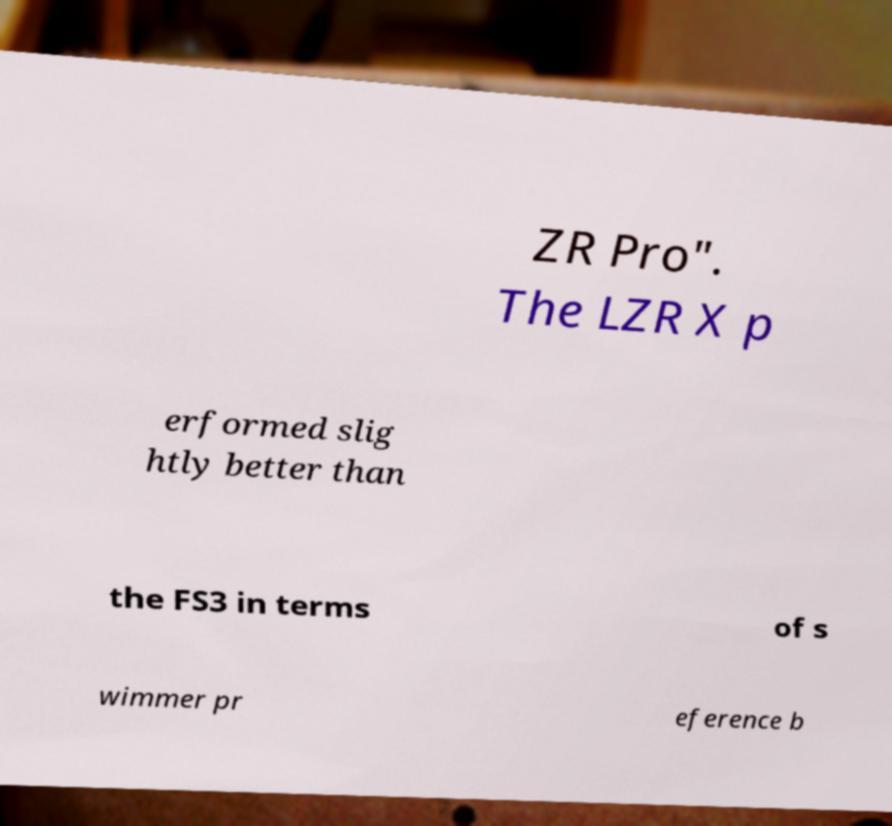I need the written content from this picture converted into text. Can you do that? ZR Pro". The LZR X p erformed slig htly better than the FS3 in terms of s wimmer pr eference b 